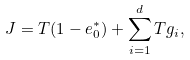Convert formula to latex. <formula><loc_0><loc_0><loc_500><loc_500>J = T ( 1 - e ^ { * } _ { 0 } ) + \sum _ { i = 1 } ^ { d } T g _ { i } ,</formula> 